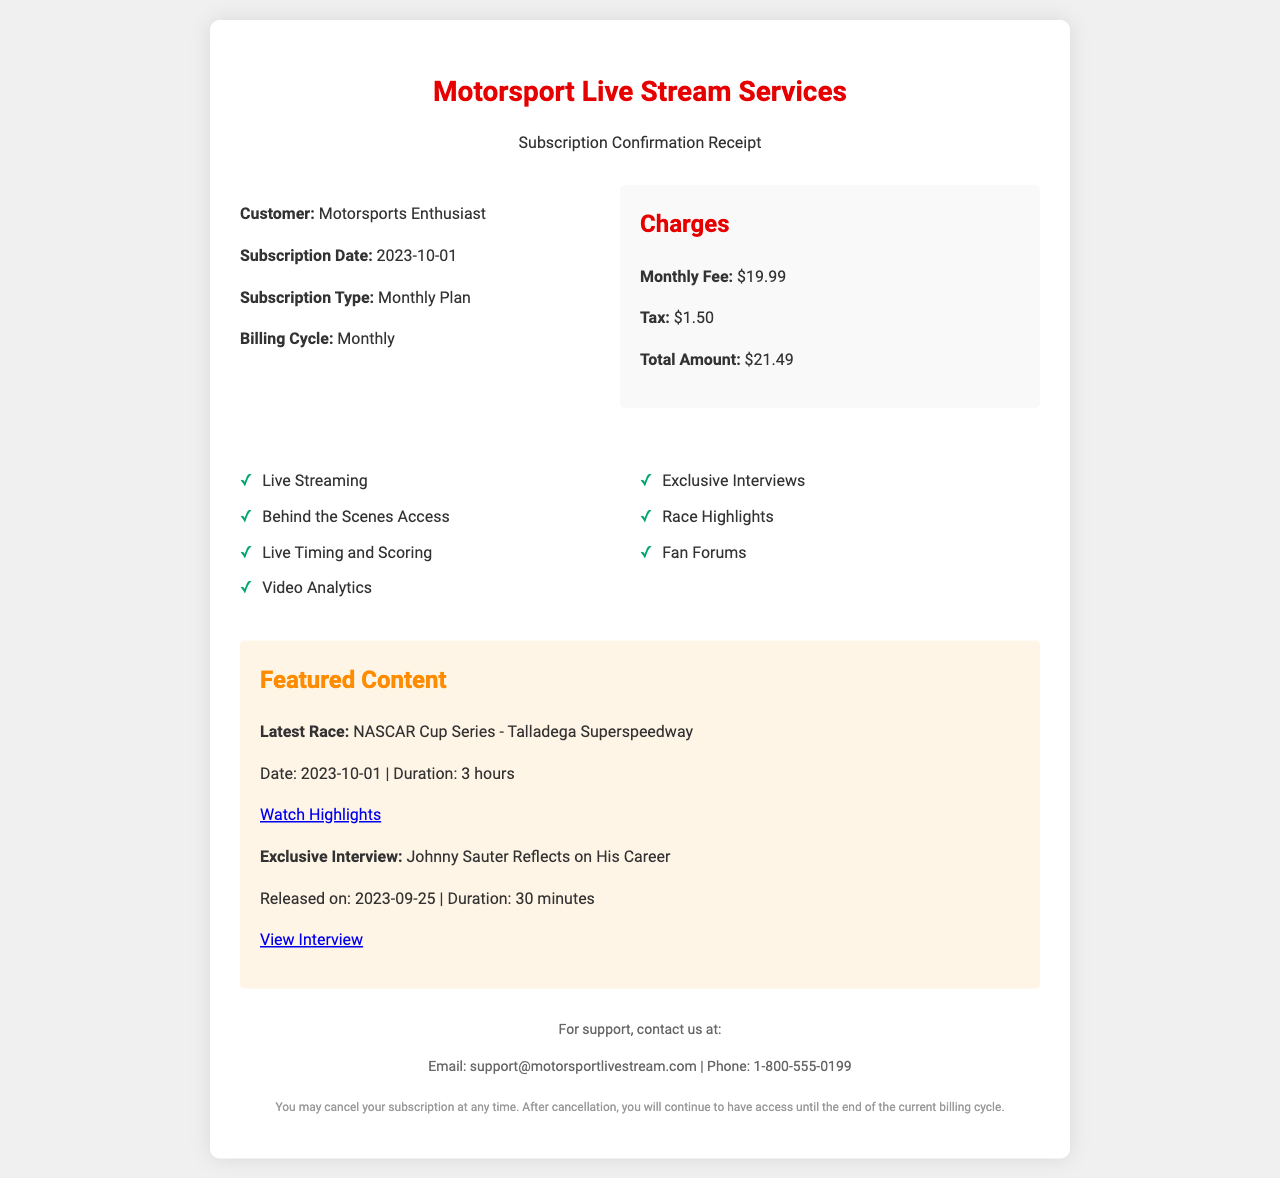What is the subscription type? The subscription type is mentioned in the "Subscription Type" section of the document, which specifies the Monthly Plan.
Answer: Monthly Plan What is the total amount charged? The total amount charged is detailed in the Charges section and sums the monthly fee and tax, resulting in the total amount.
Answer: $21.49 When was the subscription date? The subscription date is specified in the "Subscription Date" section, marking when the subscription began.
Answer: 2023-10-01 What is one of the featured content items? The document lists multiple featured content items; one example given is Johnny Sauter’s exclusive interview, which is noted in the featured content section.
Answer: Johnny Sauter Reflects on His Career How much is the monthly fee? The monthly fee amount is stated in the Charges section as part of the subscription details.
Answer: $19.99 What additional charge is applied beside the monthly fee? The document specifies that there is a tax applied to the subscription.
Answer: $1.50 What is one feature included in the subscription? The features section lists various features that are included; one example is "Live Streaming."
Answer: Live Streaming What is the email for support? The support information section provides contact details, including the email address for customer support.
Answer: support@motorsportlivestream.com When can the subscription be canceled? The cancellation policy states when a customer may cancel their subscription, which can be at any time with access until the end of the current billing cycle.
Answer: At any time 